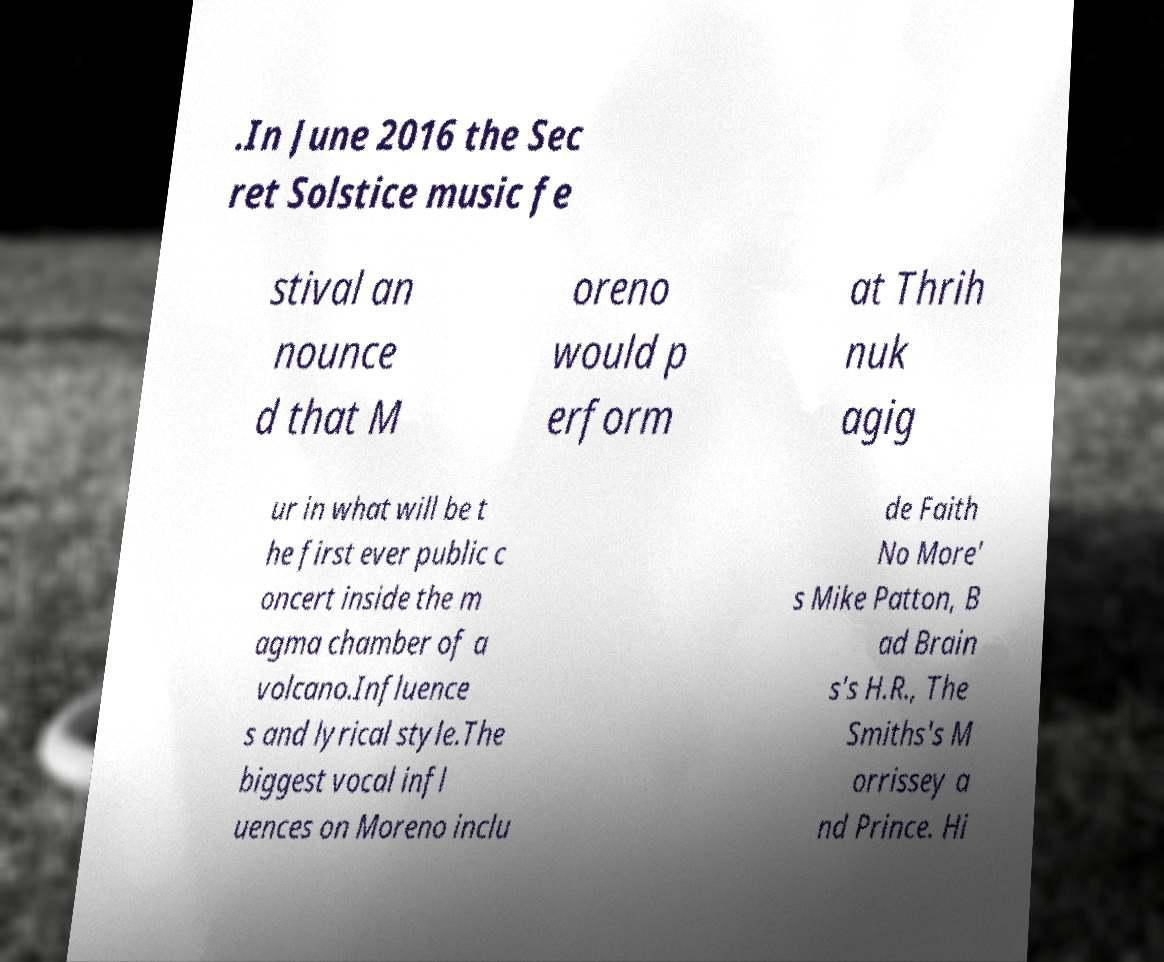I need the written content from this picture converted into text. Can you do that? .In June 2016 the Sec ret Solstice music fe stival an nounce d that M oreno would p erform at Thrih nuk agig ur in what will be t he first ever public c oncert inside the m agma chamber of a volcano.Influence s and lyrical style.The biggest vocal infl uences on Moreno inclu de Faith No More' s Mike Patton, B ad Brain s's H.R., The Smiths's M orrissey a nd Prince. Hi 